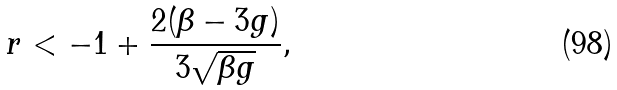Convert formula to latex. <formula><loc_0><loc_0><loc_500><loc_500>r < - 1 + \frac { 2 ( \beta - 3 g ) } { 3 \sqrt { \beta g } } ,</formula> 